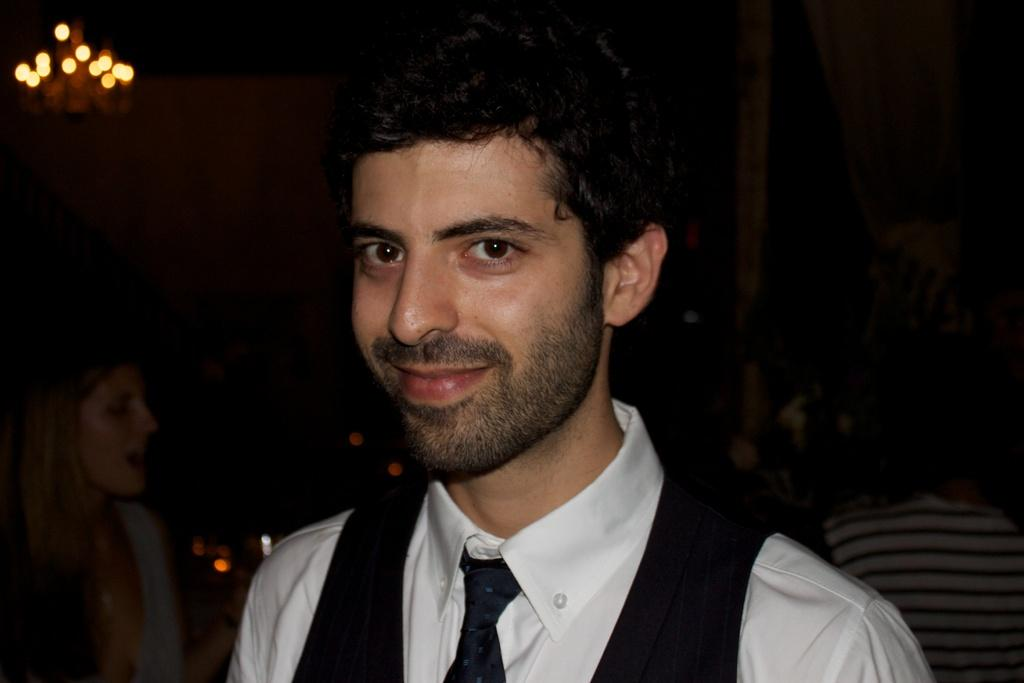What is the man in the image doing? The man is standing and smiling in the image. Can you describe the woman in the image? There is a woman in the image, but no specific details about her appearance or actions are provided. How many people are standing in the image? There is at least one person standing in the image, as the man is standing. What can be seen in the image that provides light? There is a light in the image. What object is present in the image that is typically used for support or guidance? There is a pole in the image. What type of lunch is the man eating in the image? There is no lunch present in the image; the man is standing and smiling. How many horses are visible in the image? There are no horses present in the image. 